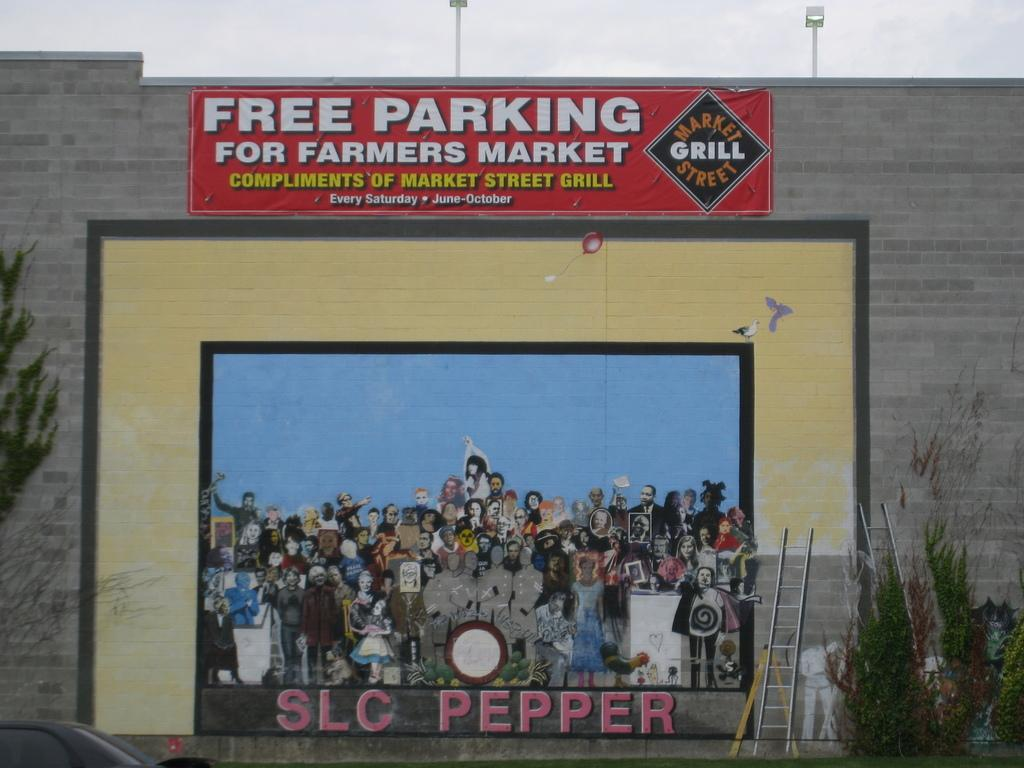Provide a one-sentence caption for the provided image. an album with SLC Pepper written at the bottom. 